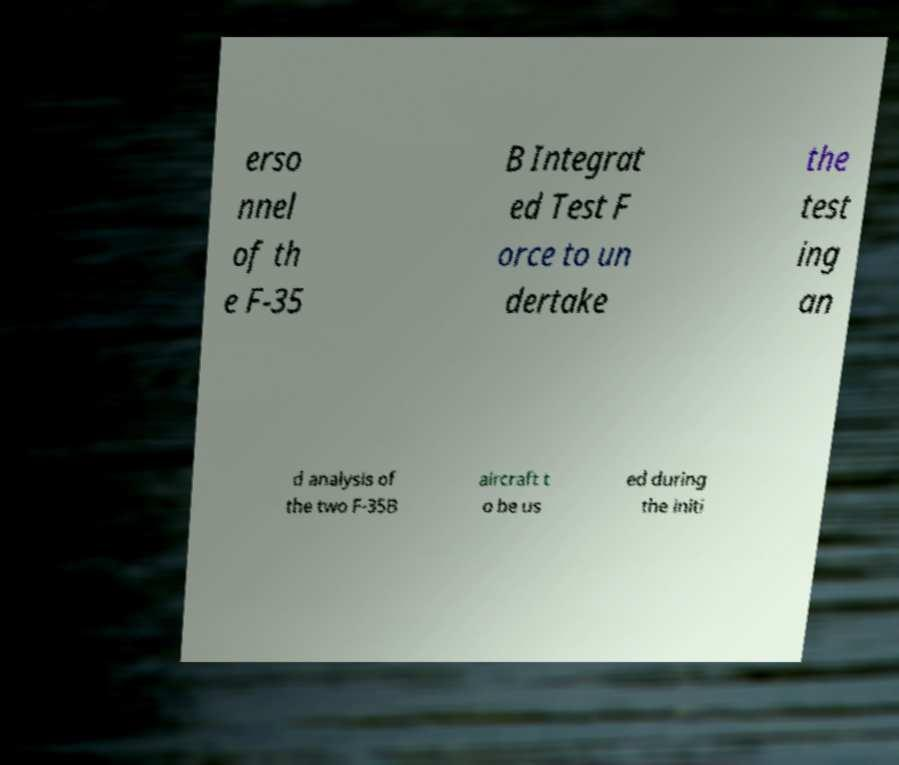For documentation purposes, I need the text within this image transcribed. Could you provide that? erso nnel of th e F-35 B Integrat ed Test F orce to un dertake the test ing an d analysis of the two F-35B aircraft t o be us ed during the initi 